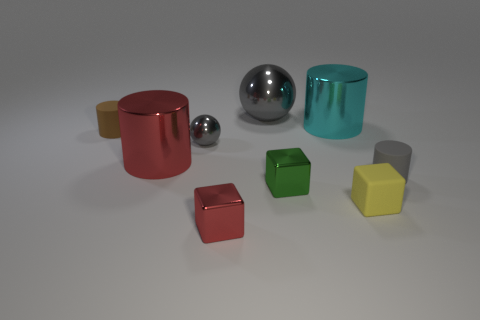Do the small brown thing and the tiny cylinder to the right of the small yellow cube have the same material?
Keep it short and to the point. Yes. What is the color of the cylinder that is both in front of the tiny brown thing and on the right side of the red cylinder?
Provide a short and direct response. Gray. How many cylinders are either large gray matte things or rubber things?
Give a very brief answer. 2. Is the shape of the small green object the same as the big thing that is right of the green metallic object?
Provide a short and direct response. No. There is a cylinder that is left of the cyan metal object and to the right of the small brown object; what size is it?
Your response must be concise. Large. What is the shape of the cyan thing?
Your answer should be very brief. Cylinder. Are there any large cylinders that are behind the tiny gray thing on the left side of the matte block?
Offer a terse response. Yes. There is a object in front of the tiny yellow cube; what number of big things are right of it?
Offer a very short reply. 2. There is a yellow object that is the same size as the brown rubber object; what is it made of?
Your answer should be very brief. Rubber. There is a gray metal object behind the small brown rubber cylinder; does it have the same shape as the large red metal object?
Your response must be concise. No. 